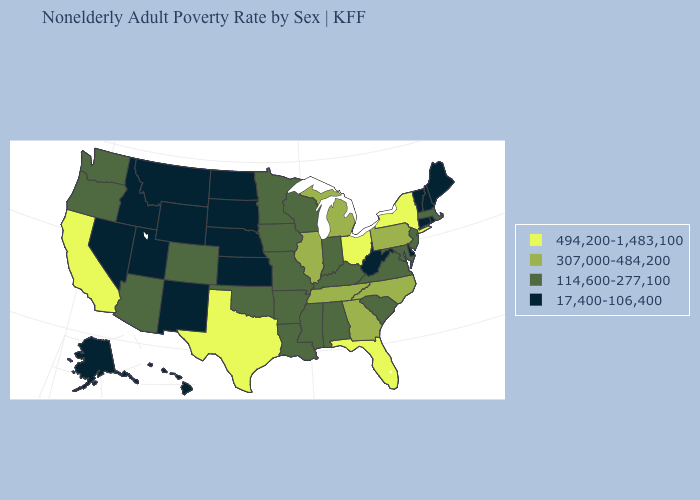Does Maryland have a lower value than Florida?
Quick response, please. Yes. What is the lowest value in the USA?
Short answer required. 17,400-106,400. Name the states that have a value in the range 17,400-106,400?
Short answer required. Alaska, Connecticut, Delaware, Hawaii, Idaho, Kansas, Maine, Montana, Nebraska, Nevada, New Hampshire, New Mexico, North Dakota, Rhode Island, South Dakota, Utah, Vermont, West Virginia, Wyoming. Does New York have the highest value in the USA?
Quick response, please. Yes. Is the legend a continuous bar?
Quick response, please. No. What is the highest value in the South ?
Write a very short answer. 494,200-1,483,100. What is the value of Arkansas?
Concise answer only. 114,600-277,100. Name the states that have a value in the range 114,600-277,100?
Concise answer only. Alabama, Arizona, Arkansas, Colorado, Indiana, Iowa, Kentucky, Louisiana, Maryland, Massachusetts, Minnesota, Mississippi, Missouri, New Jersey, Oklahoma, Oregon, South Carolina, Virginia, Washington, Wisconsin. Which states hav the highest value in the Northeast?
Give a very brief answer. New York. Which states have the lowest value in the USA?
Keep it brief. Alaska, Connecticut, Delaware, Hawaii, Idaho, Kansas, Maine, Montana, Nebraska, Nevada, New Hampshire, New Mexico, North Dakota, Rhode Island, South Dakota, Utah, Vermont, West Virginia, Wyoming. Name the states that have a value in the range 494,200-1,483,100?
Give a very brief answer. California, Florida, New York, Ohio, Texas. Name the states that have a value in the range 17,400-106,400?
Concise answer only. Alaska, Connecticut, Delaware, Hawaii, Idaho, Kansas, Maine, Montana, Nebraska, Nevada, New Hampshire, New Mexico, North Dakota, Rhode Island, South Dakota, Utah, Vermont, West Virginia, Wyoming. Name the states that have a value in the range 494,200-1,483,100?
Quick response, please. California, Florida, New York, Ohio, Texas. What is the highest value in the USA?
Write a very short answer. 494,200-1,483,100. What is the value of North Carolina?
Quick response, please. 307,000-484,200. 